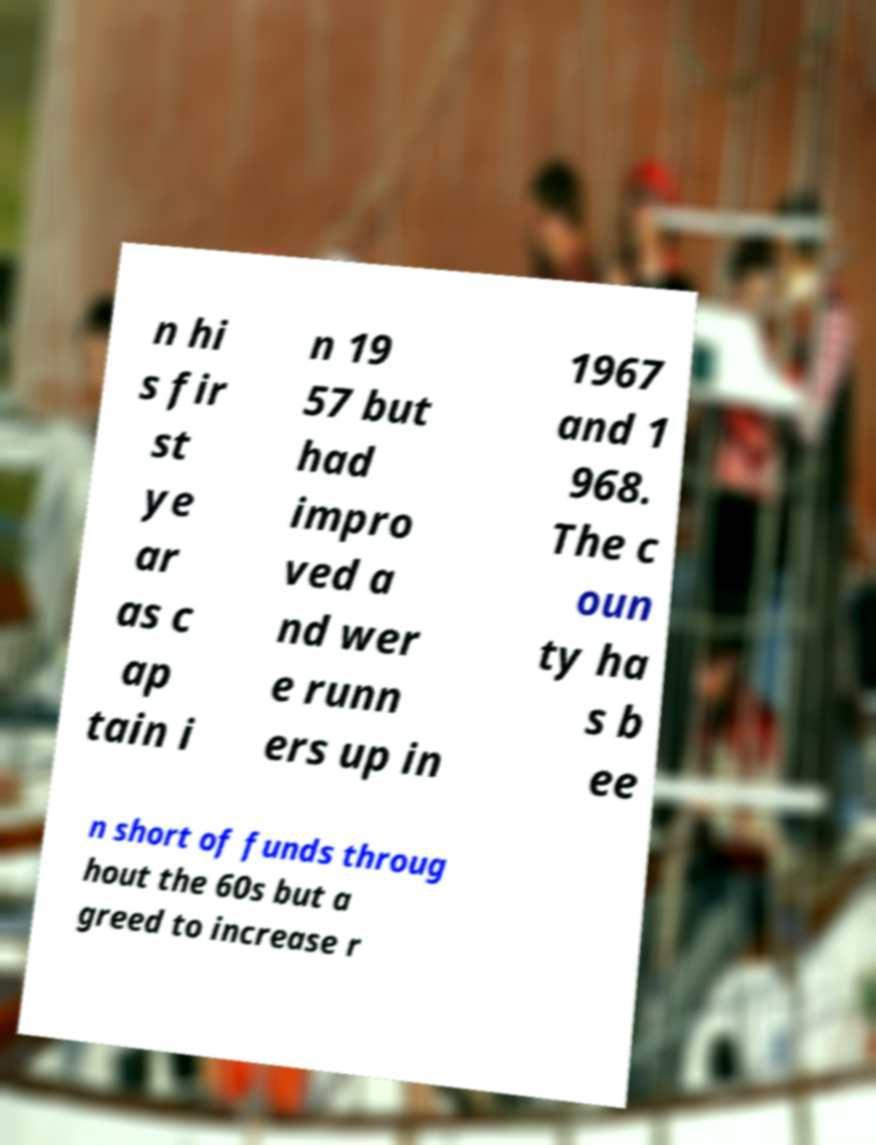There's text embedded in this image that I need extracted. Can you transcribe it verbatim? n hi s fir st ye ar as c ap tain i n 19 57 but had impro ved a nd wer e runn ers up in 1967 and 1 968. The c oun ty ha s b ee n short of funds throug hout the 60s but a greed to increase r 